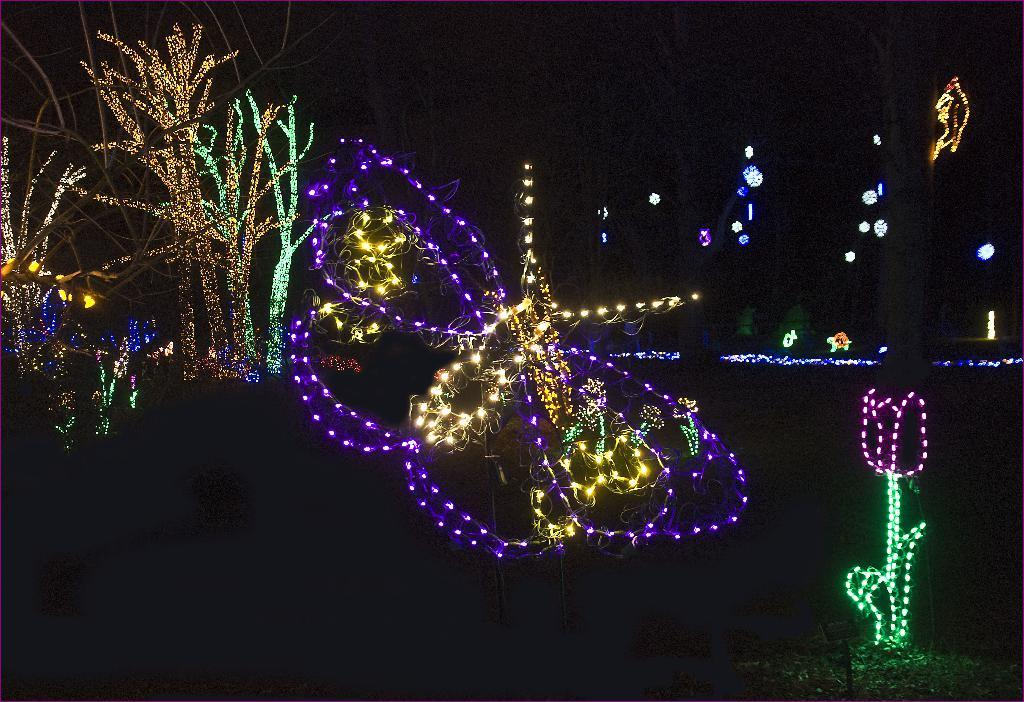What time of day is depicted in the image? The image is set during nighttime. What is illuminated in the image? There is lighting on the trees. How would you describe the overall appearance of the image? The background of the image is dark. What type of drum can be heard playing in the image? There is no drum or sound present in the image; it is a still image. 